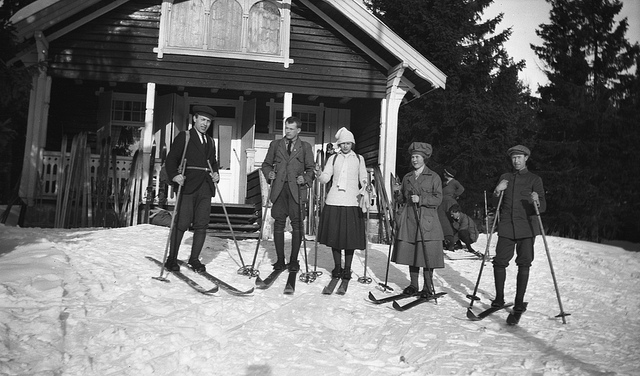<image>Do any of these skiers appear to be moving? No, none of the skiers appear to be moving. Do any of these skiers appear to be moving? No, none of these skiers appear to be moving. 